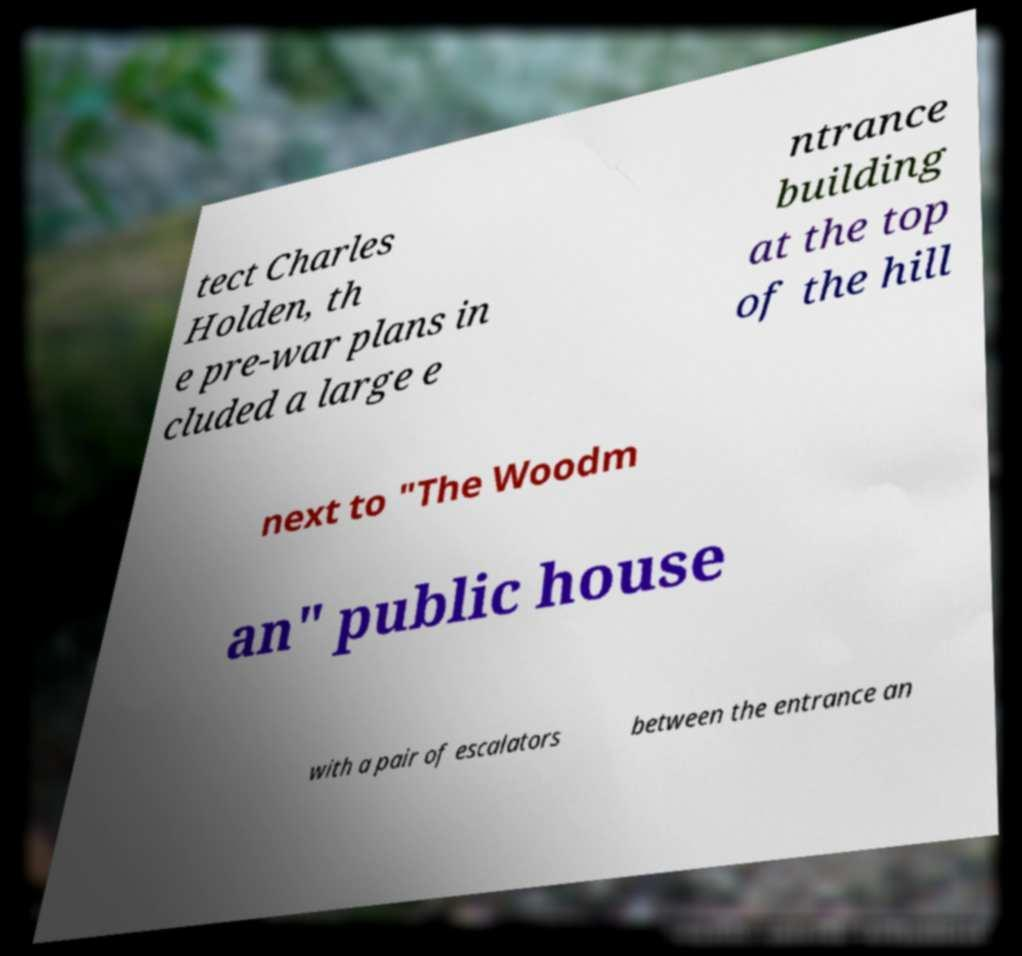For documentation purposes, I need the text within this image transcribed. Could you provide that? tect Charles Holden, th e pre-war plans in cluded a large e ntrance building at the top of the hill next to "The Woodm an" public house with a pair of escalators between the entrance an 